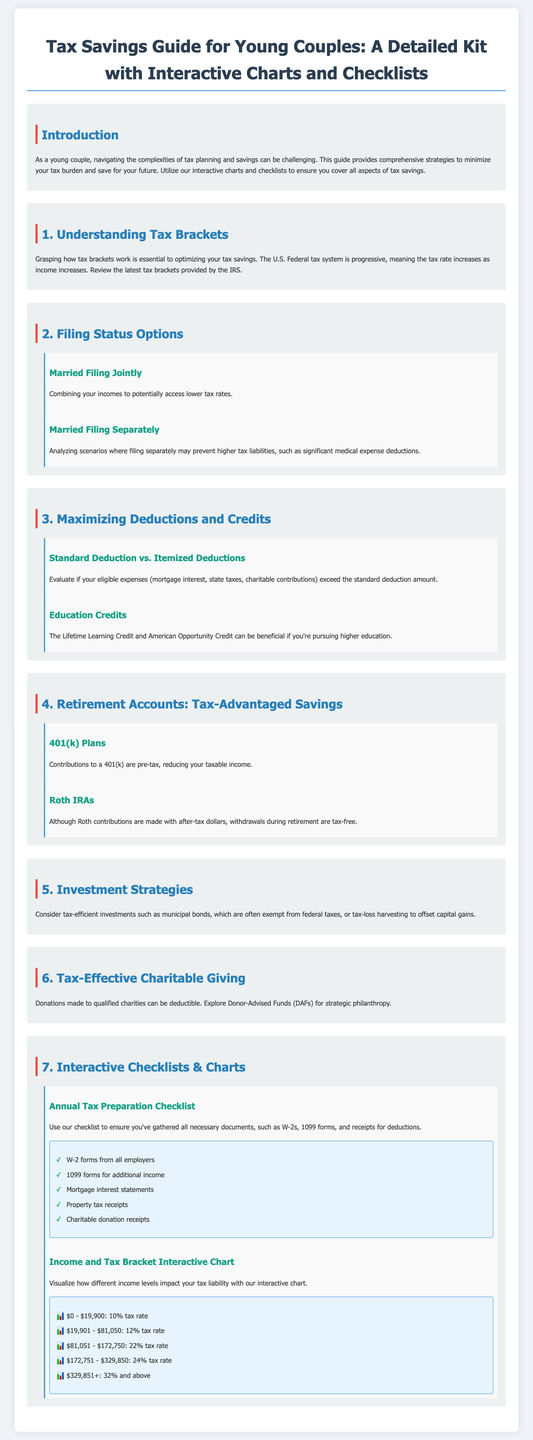what is the title of the guide? The title of the guide is explicitly stated at the top of the document.
Answer: Tax Savings Guide for Young Couples: A Detailed Kit with Interactive Charts and Checklists how many filing status options are discussed? The document lists the number of filing status options included in the section about filing status.
Answer: 2 what can be deducted under Itemized Deductions? The document mentions eligible expenses that can be itemized, including specific examples within the relevant section.
Answer: Mortgage interest, state taxes, charitable contributions what is the maximum tax rate in the income chart? The document provides a maximum tax rate for the highest income bracket in the interactive chart.
Answer: 32% and above what type of accounts are considered tax-advantaged savings? The guide specifies certain accounts that provide tax benefits within the retirement section.
Answer: 401(k) Plans and Roth IRAs which credit can benefit those pursuing higher education? The document explicitly names the education credits beneficial for individuals in higher education.
Answer: Lifetime Learning Credit and American Opportunity Credit how many items are in the annual tax preparation checklist? The document specifies items listed in the annual tax preparation checklist section.
Answer: 5 what is depicted in the Income and Tax Bracket Interactive Chart? The document explains the type of information provided in the interactive chart regarding income levels and tax rates.
Answer: Different income levels impact your tax liability 